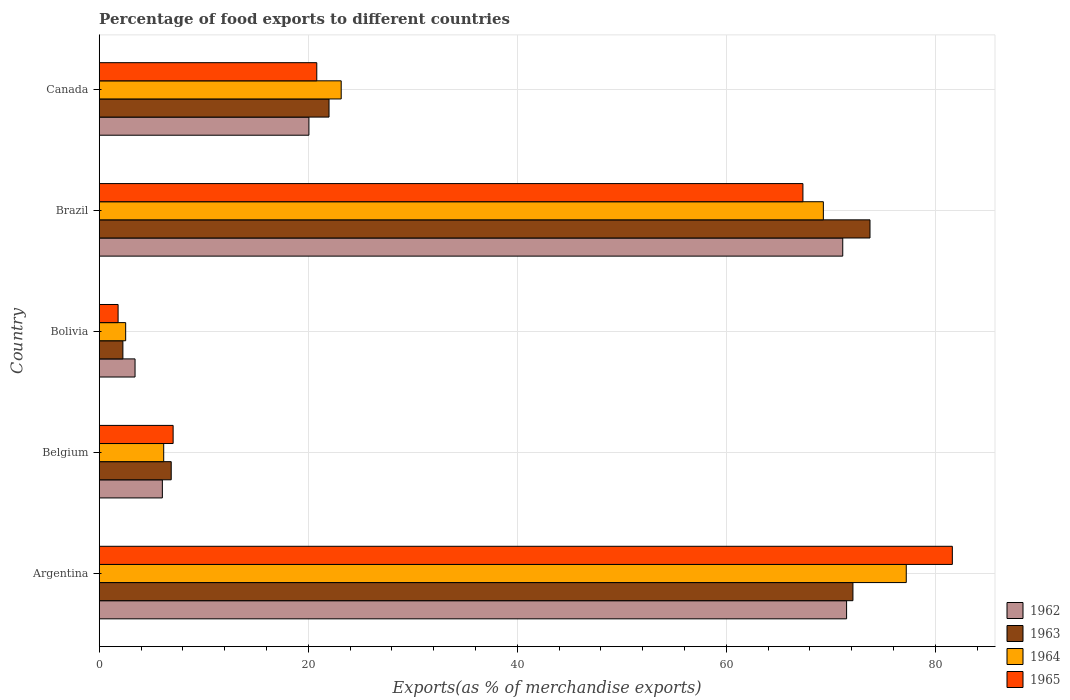How many groups of bars are there?
Your response must be concise. 5. Are the number of bars per tick equal to the number of legend labels?
Offer a very short reply. Yes. Are the number of bars on each tick of the Y-axis equal?
Provide a succinct answer. Yes. How many bars are there on the 1st tick from the bottom?
Your answer should be compact. 4. In how many cases, is the number of bars for a given country not equal to the number of legend labels?
Give a very brief answer. 0. What is the percentage of exports to different countries in 1964 in Brazil?
Your answer should be very brief. 69.29. Across all countries, what is the maximum percentage of exports to different countries in 1962?
Give a very brief answer. 71.52. Across all countries, what is the minimum percentage of exports to different countries in 1963?
Ensure brevity in your answer.  2.27. In which country was the percentage of exports to different countries in 1964 maximum?
Provide a succinct answer. Argentina. What is the total percentage of exports to different countries in 1965 in the graph?
Your response must be concise. 178.67. What is the difference between the percentage of exports to different countries in 1963 in Bolivia and that in Canada?
Provide a succinct answer. -19.72. What is the difference between the percentage of exports to different countries in 1964 in Argentina and the percentage of exports to different countries in 1963 in Belgium?
Your response must be concise. 70.34. What is the average percentage of exports to different countries in 1964 per country?
Make the answer very short. 35.68. What is the difference between the percentage of exports to different countries in 1965 and percentage of exports to different countries in 1964 in Canada?
Your answer should be very brief. -2.34. In how many countries, is the percentage of exports to different countries in 1965 greater than 76 %?
Ensure brevity in your answer.  1. What is the ratio of the percentage of exports to different countries in 1963 in Argentina to that in Canada?
Ensure brevity in your answer.  3.28. What is the difference between the highest and the second highest percentage of exports to different countries in 1962?
Offer a terse response. 0.37. What is the difference between the highest and the lowest percentage of exports to different countries in 1963?
Offer a terse response. 71.49. In how many countries, is the percentage of exports to different countries in 1962 greater than the average percentage of exports to different countries in 1962 taken over all countries?
Give a very brief answer. 2. What does the 4th bar from the top in Brazil represents?
Ensure brevity in your answer.  1962. What does the 2nd bar from the bottom in Brazil represents?
Give a very brief answer. 1963. Is it the case that in every country, the sum of the percentage of exports to different countries in 1965 and percentage of exports to different countries in 1962 is greater than the percentage of exports to different countries in 1964?
Offer a very short reply. Yes. Are all the bars in the graph horizontal?
Offer a terse response. Yes. What is the difference between two consecutive major ticks on the X-axis?
Your response must be concise. 20. Does the graph contain any zero values?
Your response must be concise. No. Where does the legend appear in the graph?
Offer a terse response. Bottom right. How many legend labels are there?
Ensure brevity in your answer.  4. What is the title of the graph?
Provide a short and direct response. Percentage of food exports to different countries. What is the label or title of the X-axis?
Ensure brevity in your answer.  Exports(as % of merchandise exports). What is the Exports(as % of merchandise exports) in 1962 in Argentina?
Your response must be concise. 71.52. What is the Exports(as % of merchandise exports) of 1963 in Argentina?
Make the answer very short. 72.12. What is the Exports(as % of merchandise exports) of 1964 in Argentina?
Offer a very short reply. 77.23. What is the Exports(as % of merchandise exports) of 1965 in Argentina?
Keep it short and to the point. 81.64. What is the Exports(as % of merchandise exports) in 1962 in Belgium?
Keep it short and to the point. 6.04. What is the Exports(as % of merchandise exports) in 1963 in Belgium?
Provide a short and direct response. 6.89. What is the Exports(as % of merchandise exports) in 1964 in Belgium?
Keep it short and to the point. 6.17. What is the Exports(as % of merchandise exports) of 1965 in Belgium?
Provide a succinct answer. 7.07. What is the Exports(as % of merchandise exports) of 1962 in Bolivia?
Your response must be concise. 3.43. What is the Exports(as % of merchandise exports) of 1963 in Bolivia?
Your response must be concise. 2.27. What is the Exports(as % of merchandise exports) of 1964 in Bolivia?
Keep it short and to the point. 2.53. What is the Exports(as % of merchandise exports) in 1965 in Bolivia?
Your answer should be compact. 1.81. What is the Exports(as % of merchandise exports) of 1962 in Brazil?
Make the answer very short. 71.15. What is the Exports(as % of merchandise exports) in 1963 in Brazil?
Provide a succinct answer. 73.76. What is the Exports(as % of merchandise exports) in 1964 in Brazil?
Your answer should be compact. 69.29. What is the Exports(as % of merchandise exports) of 1965 in Brazil?
Provide a succinct answer. 67.34. What is the Exports(as % of merchandise exports) in 1962 in Canada?
Provide a succinct answer. 20.07. What is the Exports(as % of merchandise exports) in 1963 in Canada?
Ensure brevity in your answer.  21.99. What is the Exports(as % of merchandise exports) in 1964 in Canada?
Your answer should be very brief. 23.16. What is the Exports(as % of merchandise exports) in 1965 in Canada?
Keep it short and to the point. 20.82. Across all countries, what is the maximum Exports(as % of merchandise exports) of 1962?
Your response must be concise. 71.52. Across all countries, what is the maximum Exports(as % of merchandise exports) in 1963?
Ensure brevity in your answer.  73.76. Across all countries, what is the maximum Exports(as % of merchandise exports) in 1964?
Your answer should be very brief. 77.23. Across all countries, what is the maximum Exports(as % of merchandise exports) in 1965?
Keep it short and to the point. 81.64. Across all countries, what is the minimum Exports(as % of merchandise exports) of 1962?
Keep it short and to the point. 3.43. Across all countries, what is the minimum Exports(as % of merchandise exports) in 1963?
Provide a succinct answer. 2.27. Across all countries, what is the minimum Exports(as % of merchandise exports) in 1964?
Your answer should be very brief. 2.53. Across all countries, what is the minimum Exports(as % of merchandise exports) of 1965?
Offer a terse response. 1.81. What is the total Exports(as % of merchandise exports) in 1962 in the graph?
Keep it short and to the point. 172.21. What is the total Exports(as % of merchandise exports) in 1963 in the graph?
Ensure brevity in your answer.  177.03. What is the total Exports(as % of merchandise exports) of 1964 in the graph?
Give a very brief answer. 178.38. What is the total Exports(as % of merchandise exports) of 1965 in the graph?
Give a very brief answer. 178.67. What is the difference between the Exports(as % of merchandise exports) in 1962 in Argentina and that in Belgium?
Offer a very short reply. 65.47. What is the difference between the Exports(as % of merchandise exports) in 1963 in Argentina and that in Belgium?
Your answer should be compact. 65.23. What is the difference between the Exports(as % of merchandise exports) in 1964 in Argentina and that in Belgium?
Offer a terse response. 71.06. What is the difference between the Exports(as % of merchandise exports) of 1965 in Argentina and that in Belgium?
Offer a very short reply. 74.56. What is the difference between the Exports(as % of merchandise exports) of 1962 in Argentina and that in Bolivia?
Keep it short and to the point. 68.09. What is the difference between the Exports(as % of merchandise exports) in 1963 in Argentina and that in Bolivia?
Your answer should be compact. 69.86. What is the difference between the Exports(as % of merchandise exports) in 1964 in Argentina and that in Bolivia?
Ensure brevity in your answer.  74.69. What is the difference between the Exports(as % of merchandise exports) in 1965 in Argentina and that in Bolivia?
Your answer should be very brief. 79.83. What is the difference between the Exports(as % of merchandise exports) of 1962 in Argentina and that in Brazil?
Keep it short and to the point. 0.37. What is the difference between the Exports(as % of merchandise exports) in 1963 in Argentina and that in Brazil?
Provide a short and direct response. -1.63. What is the difference between the Exports(as % of merchandise exports) of 1964 in Argentina and that in Brazil?
Keep it short and to the point. 7.93. What is the difference between the Exports(as % of merchandise exports) of 1965 in Argentina and that in Brazil?
Provide a succinct answer. 14.3. What is the difference between the Exports(as % of merchandise exports) of 1962 in Argentina and that in Canada?
Make the answer very short. 51.45. What is the difference between the Exports(as % of merchandise exports) in 1963 in Argentina and that in Canada?
Offer a very short reply. 50.13. What is the difference between the Exports(as % of merchandise exports) in 1964 in Argentina and that in Canada?
Offer a terse response. 54.07. What is the difference between the Exports(as % of merchandise exports) in 1965 in Argentina and that in Canada?
Your answer should be compact. 60.82. What is the difference between the Exports(as % of merchandise exports) in 1962 in Belgium and that in Bolivia?
Your response must be concise. 2.61. What is the difference between the Exports(as % of merchandise exports) of 1963 in Belgium and that in Bolivia?
Give a very brief answer. 4.62. What is the difference between the Exports(as % of merchandise exports) in 1964 in Belgium and that in Bolivia?
Ensure brevity in your answer.  3.64. What is the difference between the Exports(as % of merchandise exports) in 1965 in Belgium and that in Bolivia?
Offer a very short reply. 5.27. What is the difference between the Exports(as % of merchandise exports) in 1962 in Belgium and that in Brazil?
Make the answer very short. -65.11. What is the difference between the Exports(as % of merchandise exports) of 1963 in Belgium and that in Brazil?
Ensure brevity in your answer.  -66.87. What is the difference between the Exports(as % of merchandise exports) in 1964 in Belgium and that in Brazil?
Give a very brief answer. -63.12. What is the difference between the Exports(as % of merchandise exports) of 1965 in Belgium and that in Brazil?
Ensure brevity in your answer.  -60.27. What is the difference between the Exports(as % of merchandise exports) of 1962 in Belgium and that in Canada?
Offer a terse response. -14.02. What is the difference between the Exports(as % of merchandise exports) in 1963 in Belgium and that in Canada?
Provide a short and direct response. -15.1. What is the difference between the Exports(as % of merchandise exports) in 1964 in Belgium and that in Canada?
Provide a succinct answer. -16.99. What is the difference between the Exports(as % of merchandise exports) of 1965 in Belgium and that in Canada?
Offer a terse response. -13.75. What is the difference between the Exports(as % of merchandise exports) of 1962 in Bolivia and that in Brazil?
Keep it short and to the point. -67.72. What is the difference between the Exports(as % of merchandise exports) in 1963 in Bolivia and that in Brazil?
Give a very brief answer. -71.49. What is the difference between the Exports(as % of merchandise exports) of 1964 in Bolivia and that in Brazil?
Provide a short and direct response. -66.76. What is the difference between the Exports(as % of merchandise exports) in 1965 in Bolivia and that in Brazil?
Offer a very short reply. -65.53. What is the difference between the Exports(as % of merchandise exports) of 1962 in Bolivia and that in Canada?
Keep it short and to the point. -16.64. What is the difference between the Exports(as % of merchandise exports) of 1963 in Bolivia and that in Canada?
Offer a terse response. -19.72. What is the difference between the Exports(as % of merchandise exports) in 1964 in Bolivia and that in Canada?
Give a very brief answer. -20.62. What is the difference between the Exports(as % of merchandise exports) of 1965 in Bolivia and that in Canada?
Your answer should be very brief. -19.01. What is the difference between the Exports(as % of merchandise exports) in 1962 in Brazil and that in Canada?
Your answer should be very brief. 51.08. What is the difference between the Exports(as % of merchandise exports) of 1963 in Brazil and that in Canada?
Offer a terse response. 51.77. What is the difference between the Exports(as % of merchandise exports) of 1964 in Brazil and that in Canada?
Your answer should be compact. 46.14. What is the difference between the Exports(as % of merchandise exports) in 1965 in Brazil and that in Canada?
Your answer should be compact. 46.52. What is the difference between the Exports(as % of merchandise exports) of 1962 in Argentina and the Exports(as % of merchandise exports) of 1963 in Belgium?
Offer a very short reply. 64.63. What is the difference between the Exports(as % of merchandise exports) in 1962 in Argentina and the Exports(as % of merchandise exports) in 1964 in Belgium?
Your answer should be very brief. 65.35. What is the difference between the Exports(as % of merchandise exports) of 1962 in Argentina and the Exports(as % of merchandise exports) of 1965 in Belgium?
Provide a succinct answer. 64.44. What is the difference between the Exports(as % of merchandise exports) of 1963 in Argentina and the Exports(as % of merchandise exports) of 1964 in Belgium?
Keep it short and to the point. 65.95. What is the difference between the Exports(as % of merchandise exports) in 1963 in Argentina and the Exports(as % of merchandise exports) in 1965 in Belgium?
Ensure brevity in your answer.  65.05. What is the difference between the Exports(as % of merchandise exports) of 1964 in Argentina and the Exports(as % of merchandise exports) of 1965 in Belgium?
Keep it short and to the point. 70.15. What is the difference between the Exports(as % of merchandise exports) of 1962 in Argentina and the Exports(as % of merchandise exports) of 1963 in Bolivia?
Provide a succinct answer. 69.25. What is the difference between the Exports(as % of merchandise exports) of 1962 in Argentina and the Exports(as % of merchandise exports) of 1964 in Bolivia?
Your answer should be compact. 68.98. What is the difference between the Exports(as % of merchandise exports) of 1962 in Argentina and the Exports(as % of merchandise exports) of 1965 in Bolivia?
Your response must be concise. 69.71. What is the difference between the Exports(as % of merchandise exports) of 1963 in Argentina and the Exports(as % of merchandise exports) of 1964 in Bolivia?
Provide a short and direct response. 69.59. What is the difference between the Exports(as % of merchandise exports) in 1963 in Argentina and the Exports(as % of merchandise exports) in 1965 in Bolivia?
Provide a succinct answer. 70.32. What is the difference between the Exports(as % of merchandise exports) of 1964 in Argentina and the Exports(as % of merchandise exports) of 1965 in Bolivia?
Keep it short and to the point. 75.42. What is the difference between the Exports(as % of merchandise exports) in 1962 in Argentina and the Exports(as % of merchandise exports) in 1963 in Brazil?
Your answer should be very brief. -2.24. What is the difference between the Exports(as % of merchandise exports) of 1962 in Argentina and the Exports(as % of merchandise exports) of 1964 in Brazil?
Ensure brevity in your answer.  2.22. What is the difference between the Exports(as % of merchandise exports) in 1962 in Argentina and the Exports(as % of merchandise exports) in 1965 in Brazil?
Make the answer very short. 4.18. What is the difference between the Exports(as % of merchandise exports) of 1963 in Argentina and the Exports(as % of merchandise exports) of 1964 in Brazil?
Provide a short and direct response. 2.83. What is the difference between the Exports(as % of merchandise exports) of 1963 in Argentina and the Exports(as % of merchandise exports) of 1965 in Brazil?
Make the answer very short. 4.79. What is the difference between the Exports(as % of merchandise exports) of 1964 in Argentina and the Exports(as % of merchandise exports) of 1965 in Brazil?
Your answer should be very brief. 9.89. What is the difference between the Exports(as % of merchandise exports) in 1962 in Argentina and the Exports(as % of merchandise exports) in 1963 in Canada?
Offer a very short reply. 49.53. What is the difference between the Exports(as % of merchandise exports) in 1962 in Argentina and the Exports(as % of merchandise exports) in 1964 in Canada?
Your answer should be compact. 48.36. What is the difference between the Exports(as % of merchandise exports) of 1962 in Argentina and the Exports(as % of merchandise exports) of 1965 in Canada?
Provide a short and direct response. 50.7. What is the difference between the Exports(as % of merchandise exports) in 1963 in Argentina and the Exports(as % of merchandise exports) in 1964 in Canada?
Give a very brief answer. 48.97. What is the difference between the Exports(as % of merchandise exports) of 1963 in Argentina and the Exports(as % of merchandise exports) of 1965 in Canada?
Give a very brief answer. 51.31. What is the difference between the Exports(as % of merchandise exports) in 1964 in Argentina and the Exports(as % of merchandise exports) in 1965 in Canada?
Ensure brevity in your answer.  56.41. What is the difference between the Exports(as % of merchandise exports) in 1962 in Belgium and the Exports(as % of merchandise exports) in 1963 in Bolivia?
Give a very brief answer. 3.78. What is the difference between the Exports(as % of merchandise exports) in 1962 in Belgium and the Exports(as % of merchandise exports) in 1964 in Bolivia?
Provide a succinct answer. 3.51. What is the difference between the Exports(as % of merchandise exports) of 1962 in Belgium and the Exports(as % of merchandise exports) of 1965 in Bolivia?
Provide a succinct answer. 4.24. What is the difference between the Exports(as % of merchandise exports) in 1963 in Belgium and the Exports(as % of merchandise exports) in 1964 in Bolivia?
Offer a terse response. 4.36. What is the difference between the Exports(as % of merchandise exports) in 1963 in Belgium and the Exports(as % of merchandise exports) in 1965 in Bolivia?
Provide a succinct answer. 5.08. What is the difference between the Exports(as % of merchandise exports) of 1964 in Belgium and the Exports(as % of merchandise exports) of 1965 in Bolivia?
Give a very brief answer. 4.36. What is the difference between the Exports(as % of merchandise exports) of 1962 in Belgium and the Exports(as % of merchandise exports) of 1963 in Brazil?
Your answer should be very brief. -67.71. What is the difference between the Exports(as % of merchandise exports) of 1962 in Belgium and the Exports(as % of merchandise exports) of 1964 in Brazil?
Ensure brevity in your answer.  -63.25. What is the difference between the Exports(as % of merchandise exports) in 1962 in Belgium and the Exports(as % of merchandise exports) in 1965 in Brazil?
Provide a short and direct response. -61.3. What is the difference between the Exports(as % of merchandise exports) of 1963 in Belgium and the Exports(as % of merchandise exports) of 1964 in Brazil?
Offer a terse response. -62.4. What is the difference between the Exports(as % of merchandise exports) in 1963 in Belgium and the Exports(as % of merchandise exports) in 1965 in Brazil?
Offer a very short reply. -60.45. What is the difference between the Exports(as % of merchandise exports) in 1964 in Belgium and the Exports(as % of merchandise exports) in 1965 in Brazil?
Ensure brevity in your answer.  -61.17. What is the difference between the Exports(as % of merchandise exports) in 1962 in Belgium and the Exports(as % of merchandise exports) in 1963 in Canada?
Ensure brevity in your answer.  -15.95. What is the difference between the Exports(as % of merchandise exports) in 1962 in Belgium and the Exports(as % of merchandise exports) in 1964 in Canada?
Ensure brevity in your answer.  -17.11. What is the difference between the Exports(as % of merchandise exports) of 1962 in Belgium and the Exports(as % of merchandise exports) of 1965 in Canada?
Your answer should be compact. -14.78. What is the difference between the Exports(as % of merchandise exports) in 1963 in Belgium and the Exports(as % of merchandise exports) in 1964 in Canada?
Offer a very short reply. -16.27. What is the difference between the Exports(as % of merchandise exports) in 1963 in Belgium and the Exports(as % of merchandise exports) in 1965 in Canada?
Make the answer very short. -13.93. What is the difference between the Exports(as % of merchandise exports) of 1964 in Belgium and the Exports(as % of merchandise exports) of 1965 in Canada?
Ensure brevity in your answer.  -14.65. What is the difference between the Exports(as % of merchandise exports) in 1962 in Bolivia and the Exports(as % of merchandise exports) in 1963 in Brazil?
Your answer should be very brief. -70.33. What is the difference between the Exports(as % of merchandise exports) of 1962 in Bolivia and the Exports(as % of merchandise exports) of 1964 in Brazil?
Offer a very short reply. -65.86. What is the difference between the Exports(as % of merchandise exports) in 1962 in Bolivia and the Exports(as % of merchandise exports) in 1965 in Brazil?
Your response must be concise. -63.91. What is the difference between the Exports(as % of merchandise exports) in 1963 in Bolivia and the Exports(as % of merchandise exports) in 1964 in Brazil?
Give a very brief answer. -67.03. What is the difference between the Exports(as % of merchandise exports) of 1963 in Bolivia and the Exports(as % of merchandise exports) of 1965 in Brazil?
Give a very brief answer. -65.07. What is the difference between the Exports(as % of merchandise exports) in 1964 in Bolivia and the Exports(as % of merchandise exports) in 1965 in Brazil?
Give a very brief answer. -64.81. What is the difference between the Exports(as % of merchandise exports) of 1962 in Bolivia and the Exports(as % of merchandise exports) of 1963 in Canada?
Provide a succinct answer. -18.56. What is the difference between the Exports(as % of merchandise exports) of 1962 in Bolivia and the Exports(as % of merchandise exports) of 1964 in Canada?
Provide a succinct answer. -19.73. What is the difference between the Exports(as % of merchandise exports) of 1962 in Bolivia and the Exports(as % of merchandise exports) of 1965 in Canada?
Provide a succinct answer. -17.39. What is the difference between the Exports(as % of merchandise exports) of 1963 in Bolivia and the Exports(as % of merchandise exports) of 1964 in Canada?
Offer a terse response. -20.89. What is the difference between the Exports(as % of merchandise exports) of 1963 in Bolivia and the Exports(as % of merchandise exports) of 1965 in Canada?
Offer a very short reply. -18.55. What is the difference between the Exports(as % of merchandise exports) in 1964 in Bolivia and the Exports(as % of merchandise exports) in 1965 in Canada?
Your answer should be compact. -18.29. What is the difference between the Exports(as % of merchandise exports) of 1962 in Brazil and the Exports(as % of merchandise exports) of 1963 in Canada?
Give a very brief answer. 49.16. What is the difference between the Exports(as % of merchandise exports) of 1962 in Brazil and the Exports(as % of merchandise exports) of 1964 in Canada?
Provide a short and direct response. 47.99. What is the difference between the Exports(as % of merchandise exports) in 1962 in Brazil and the Exports(as % of merchandise exports) in 1965 in Canada?
Keep it short and to the point. 50.33. What is the difference between the Exports(as % of merchandise exports) of 1963 in Brazil and the Exports(as % of merchandise exports) of 1964 in Canada?
Give a very brief answer. 50.6. What is the difference between the Exports(as % of merchandise exports) in 1963 in Brazil and the Exports(as % of merchandise exports) in 1965 in Canada?
Provide a succinct answer. 52.94. What is the difference between the Exports(as % of merchandise exports) in 1964 in Brazil and the Exports(as % of merchandise exports) in 1965 in Canada?
Your response must be concise. 48.48. What is the average Exports(as % of merchandise exports) of 1962 per country?
Offer a terse response. 34.44. What is the average Exports(as % of merchandise exports) in 1963 per country?
Your answer should be very brief. 35.41. What is the average Exports(as % of merchandise exports) in 1964 per country?
Provide a succinct answer. 35.68. What is the average Exports(as % of merchandise exports) in 1965 per country?
Make the answer very short. 35.73. What is the difference between the Exports(as % of merchandise exports) in 1962 and Exports(as % of merchandise exports) in 1963 in Argentina?
Give a very brief answer. -0.61. What is the difference between the Exports(as % of merchandise exports) of 1962 and Exports(as % of merchandise exports) of 1964 in Argentina?
Make the answer very short. -5.71. What is the difference between the Exports(as % of merchandise exports) of 1962 and Exports(as % of merchandise exports) of 1965 in Argentina?
Offer a terse response. -10.12. What is the difference between the Exports(as % of merchandise exports) of 1963 and Exports(as % of merchandise exports) of 1964 in Argentina?
Keep it short and to the point. -5.1. What is the difference between the Exports(as % of merchandise exports) of 1963 and Exports(as % of merchandise exports) of 1965 in Argentina?
Give a very brief answer. -9.51. What is the difference between the Exports(as % of merchandise exports) in 1964 and Exports(as % of merchandise exports) in 1965 in Argentina?
Provide a short and direct response. -4.41. What is the difference between the Exports(as % of merchandise exports) of 1962 and Exports(as % of merchandise exports) of 1963 in Belgium?
Offer a terse response. -0.85. What is the difference between the Exports(as % of merchandise exports) of 1962 and Exports(as % of merchandise exports) of 1964 in Belgium?
Keep it short and to the point. -0.13. What is the difference between the Exports(as % of merchandise exports) of 1962 and Exports(as % of merchandise exports) of 1965 in Belgium?
Your response must be concise. -1.03. What is the difference between the Exports(as % of merchandise exports) of 1963 and Exports(as % of merchandise exports) of 1964 in Belgium?
Your answer should be very brief. 0.72. What is the difference between the Exports(as % of merchandise exports) of 1963 and Exports(as % of merchandise exports) of 1965 in Belgium?
Offer a terse response. -0.18. What is the difference between the Exports(as % of merchandise exports) in 1964 and Exports(as % of merchandise exports) in 1965 in Belgium?
Provide a succinct answer. -0.9. What is the difference between the Exports(as % of merchandise exports) in 1962 and Exports(as % of merchandise exports) in 1963 in Bolivia?
Provide a short and direct response. 1.16. What is the difference between the Exports(as % of merchandise exports) in 1962 and Exports(as % of merchandise exports) in 1964 in Bolivia?
Offer a very short reply. 0.9. What is the difference between the Exports(as % of merchandise exports) in 1962 and Exports(as % of merchandise exports) in 1965 in Bolivia?
Provide a short and direct response. 1.62. What is the difference between the Exports(as % of merchandise exports) of 1963 and Exports(as % of merchandise exports) of 1964 in Bolivia?
Provide a short and direct response. -0.27. What is the difference between the Exports(as % of merchandise exports) of 1963 and Exports(as % of merchandise exports) of 1965 in Bolivia?
Offer a very short reply. 0.46. What is the difference between the Exports(as % of merchandise exports) in 1964 and Exports(as % of merchandise exports) in 1965 in Bolivia?
Provide a short and direct response. 0.73. What is the difference between the Exports(as % of merchandise exports) in 1962 and Exports(as % of merchandise exports) in 1963 in Brazil?
Provide a short and direct response. -2.61. What is the difference between the Exports(as % of merchandise exports) of 1962 and Exports(as % of merchandise exports) of 1964 in Brazil?
Give a very brief answer. 1.86. What is the difference between the Exports(as % of merchandise exports) in 1962 and Exports(as % of merchandise exports) in 1965 in Brazil?
Your answer should be very brief. 3.81. What is the difference between the Exports(as % of merchandise exports) in 1963 and Exports(as % of merchandise exports) in 1964 in Brazil?
Your answer should be compact. 4.46. What is the difference between the Exports(as % of merchandise exports) of 1963 and Exports(as % of merchandise exports) of 1965 in Brazil?
Keep it short and to the point. 6.42. What is the difference between the Exports(as % of merchandise exports) in 1964 and Exports(as % of merchandise exports) in 1965 in Brazil?
Ensure brevity in your answer.  1.96. What is the difference between the Exports(as % of merchandise exports) of 1962 and Exports(as % of merchandise exports) of 1963 in Canada?
Offer a terse response. -1.92. What is the difference between the Exports(as % of merchandise exports) of 1962 and Exports(as % of merchandise exports) of 1964 in Canada?
Your answer should be very brief. -3.09. What is the difference between the Exports(as % of merchandise exports) in 1962 and Exports(as % of merchandise exports) in 1965 in Canada?
Give a very brief answer. -0.75. What is the difference between the Exports(as % of merchandise exports) in 1963 and Exports(as % of merchandise exports) in 1964 in Canada?
Offer a terse response. -1.17. What is the difference between the Exports(as % of merchandise exports) of 1963 and Exports(as % of merchandise exports) of 1965 in Canada?
Keep it short and to the point. 1.17. What is the difference between the Exports(as % of merchandise exports) of 1964 and Exports(as % of merchandise exports) of 1965 in Canada?
Give a very brief answer. 2.34. What is the ratio of the Exports(as % of merchandise exports) of 1962 in Argentina to that in Belgium?
Your response must be concise. 11.84. What is the ratio of the Exports(as % of merchandise exports) in 1963 in Argentina to that in Belgium?
Your answer should be compact. 10.47. What is the ratio of the Exports(as % of merchandise exports) of 1964 in Argentina to that in Belgium?
Offer a terse response. 12.52. What is the ratio of the Exports(as % of merchandise exports) in 1965 in Argentina to that in Belgium?
Provide a short and direct response. 11.54. What is the ratio of the Exports(as % of merchandise exports) of 1962 in Argentina to that in Bolivia?
Offer a very short reply. 20.86. What is the ratio of the Exports(as % of merchandise exports) in 1963 in Argentina to that in Bolivia?
Your answer should be compact. 31.83. What is the ratio of the Exports(as % of merchandise exports) in 1964 in Argentina to that in Bolivia?
Your response must be concise. 30.5. What is the ratio of the Exports(as % of merchandise exports) in 1965 in Argentina to that in Bolivia?
Provide a succinct answer. 45.18. What is the ratio of the Exports(as % of merchandise exports) in 1962 in Argentina to that in Brazil?
Provide a succinct answer. 1.01. What is the ratio of the Exports(as % of merchandise exports) of 1963 in Argentina to that in Brazil?
Make the answer very short. 0.98. What is the ratio of the Exports(as % of merchandise exports) of 1964 in Argentina to that in Brazil?
Give a very brief answer. 1.11. What is the ratio of the Exports(as % of merchandise exports) in 1965 in Argentina to that in Brazil?
Your response must be concise. 1.21. What is the ratio of the Exports(as % of merchandise exports) of 1962 in Argentina to that in Canada?
Offer a very short reply. 3.56. What is the ratio of the Exports(as % of merchandise exports) of 1963 in Argentina to that in Canada?
Offer a very short reply. 3.28. What is the ratio of the Exports(as % of merchandise exports) of 1964 in Argentina to that in Canada?
Give a very brief answer. 3.34. What is the ratio of the Exports(as % of merchandise exports) in 1965 in Argentina to that in Canada?
Offer a very short reply. 3.92. What is the ratio of the Exports(as % of merchandise exports) in 1962 in Belgium to that in Bolivia?
Your answer should be very brief. 1.76. What is the ratio of the Exports(as % of merchandise exports) in 1963 in Belgium to that in Bolivia?
Keep it short and to the point. 3.04. What is the ratio of the Exports(as % of merchandise exports) in 1964 in Belgium to that in Bolivia?
Offer a terse response. 2.44. What is the ratio of the Exports(as % of merchandise exports) of 1965 in Belgium to that in Bolivia?
Provide a succinct answer. 3.91. What is the ratio of the Exports(as % of merchandise exports) in 1962 in Belgium to that in Brazil?
Offer a very short reply. 0.08. What is the ratio of the Exports(as % of merchandise exports) in 1963 in Belgium to that in Brazil?
Keep it short and to the point. 0.09. What is the ratio of the Exports(as % of merchandise exports) of 1964 in Belgium to that in Brazil?
Offer a terse response. 0.09. What is the ratio of the Exports(as % of merchandise exports) of 1965 in Belgium to that in Brazil?
Keep it short and to the point. 0.1. What is the ratio of the Exports(as % of merchandise exports) of 1962 in Belgium to that in Canada?
Ensure brevity in your answer.  0.3. What is the ratio of the Exports(as % of merchandise exports) of 1963 in Belgium to that in Canada?
Give a very brief answer. 0.31. What is the ratio of the Exports(as % of merchandise exports) of 1964 in Belgium to that in Canada?
Give a very brief answer. 0.27. What is the ratio of the Exports(as % of merchandise exports) of 1965 in Belgium to that in Canada?
Your answer should be compact. 0.34. What is the ratio of the Exports(as % of merchandise exports) in 1962 in Bolivia to that in Brazil?
Your answer should be very brief. 0.05. What is the ratio of the Exports(as % of merchandise exports) in 1963 in Bolivia to that in Brazil?
Ensure brevity in your answer.  0.03. What is the ratio of the Exports(as % of merchandise exports) in 1964 in Bolivia to that in Brazil?
Offer a terse response. 0.04. What is the ratio of the Exports(as % of merchandise exports) of 1965 in Bolivia to that in Brazil?
Ensure brevity in your answer.  0.03. What is the ratio of the Exports(as % of merchandise exports) in 1962 in Bolivia to that in Canada?
Give a very brief answer. 0.17. What is the ratio of the Exports(as % of merchandise exports) in 1963 in Bolivia to that in Canada?
Provide a succinct answer. 0.1. What is the ratio of the Exports(as % of merchandise exports) in 1964 in Bolivia to that in Canada?
Offer a terse response. 0.11. What is the ratio of the Exports(as % of merchandise exports) of 1965 in Bolivia to that in Canada?
Keep it short and to the point. 0.09. What is the ratio of the Exports(as % of merchandise exports) of 1962 in Brazil to that in Canada?
Your response must be concise. 3.55. What is the ratio of the Exports(as % of merchandise exports) in 1963 in Brazil to that in Canada?
Your answer should be very brief. 3.35. What is the ratio of the Exports(as % of merchandise exports) in 1964 in Brazil to that in Canada?
Your answer should be compact. 2.99. What is the ratio of the Exports(as % of merchandise exports) of 1965 in Brazil to that in Canada?
Ensure brevity in your answer.  3.23. What is the difference between the highest and the second highest Exports(as % of merchandise exports) in 1962?
Your answer should be compact. 0.37. What is the difference between the highest and the second highest Exports(as % of merchandise exports) in 1963?
Make the answer very short. 1.63. What is the difference between the highest and the second highest Exports(as % of merchandise exports) in 1964?
Your answer should be very brief. 7.93. What is the difference between the highest and the second highest Exports(as % of merchandise exports) in 1965?
Provide a short and direct response. 14.3. What is the difference between the highest and the lowest Exports(as % of merchandise exports) of 1962?
Keep it short and to the point. 68.09. What is the difference between the highest and the lowest Exports(as % of merchandise exports) in 1963?
Your answer should be very brief. 71.49. What is the difference between the highest and the lowest Exports(as % of merchandise exports) of 1964?
Give a very brief answer. 74.69. What is the difference between the highest and the lowest Exports(as % of merchandise exports) in 1965?
Provide a short and direct response. 79.83. 